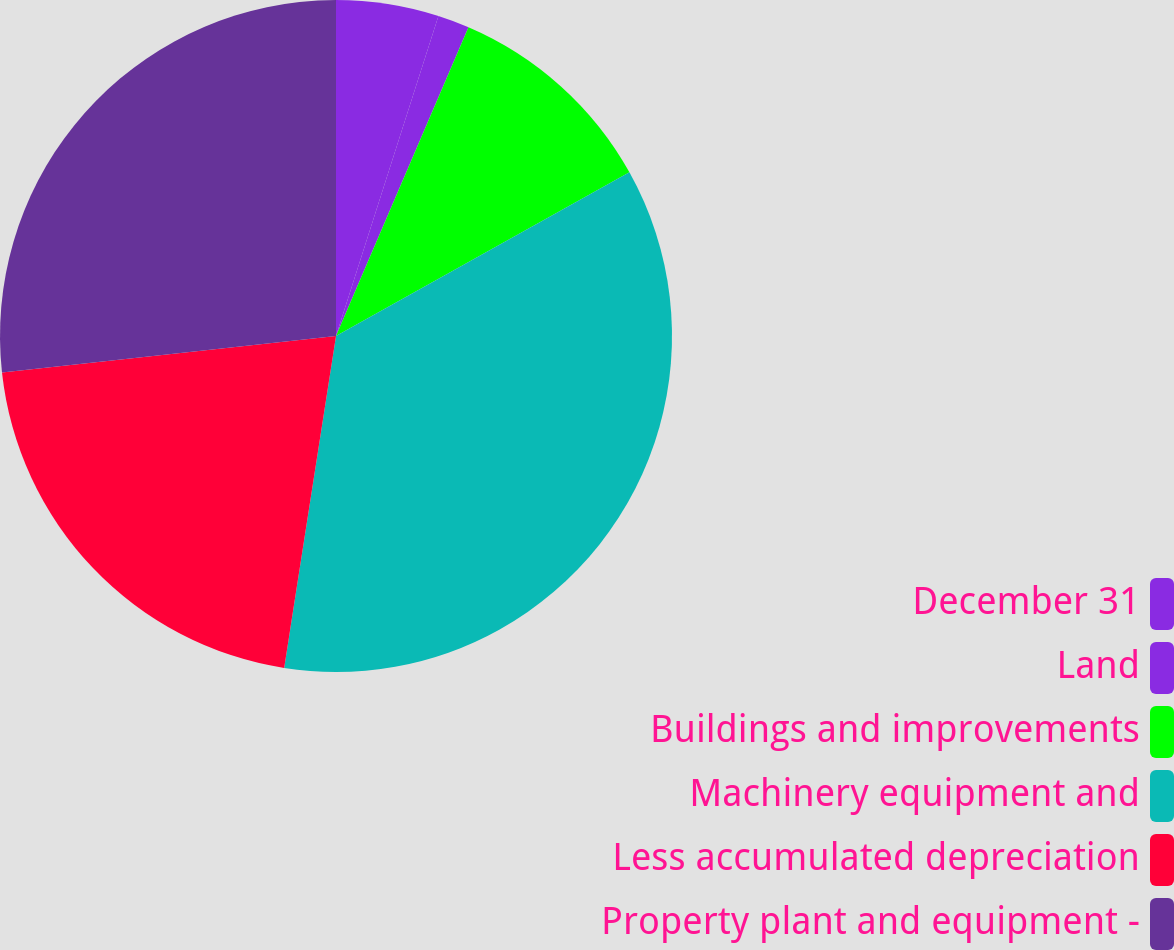Convert chart. <chart><loc_0><loc_0><loc_500><loc_500><pie_chart><fcel>December 31<fcel>Land<fcel>Buildings and improvements<fcel>Machinery equipment and<fcel>Less accumulated depreciation<fcel>Property plant and equipment -<nl><fcel>4.93%<fcel>1.52%<fcel>10.45%<fcel>35.56%<fcel>20.8%<fcel>26.73%<nl></chart> 